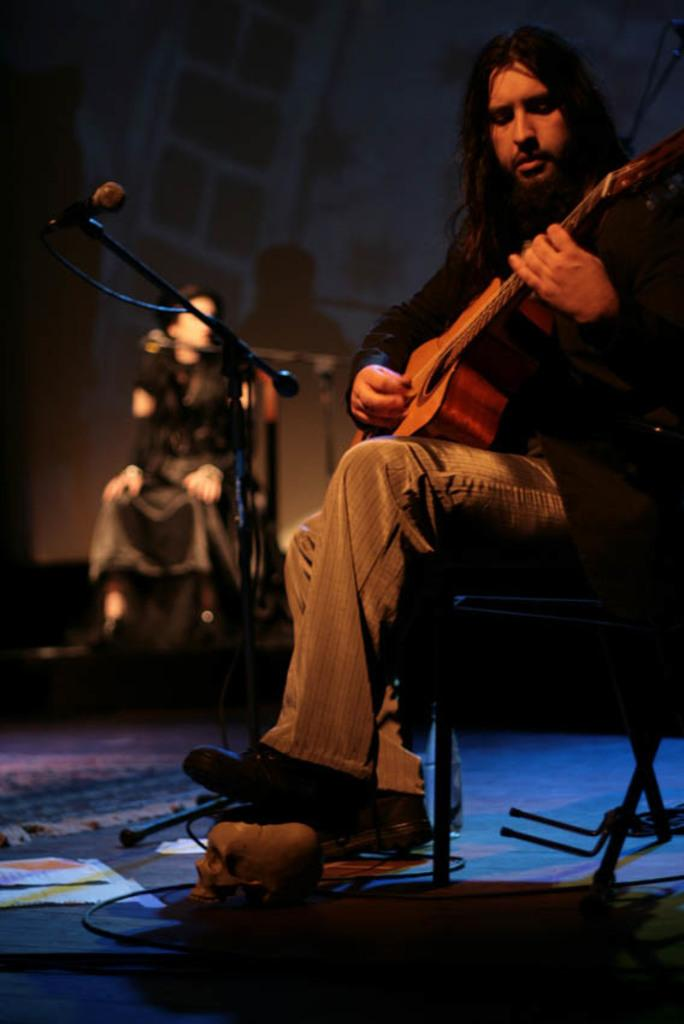What is the main subject of the image? There is a person in the image. What is the person doing in the image? The person is sitting and playing the guitar. What level of expertise does the person have in playing the guitar in the image? The image does not provide information about the person's level of expertise in playing the guitar. What type of brake can be seen on the guitar in the image? There is no brake present on the guitar in the image. 